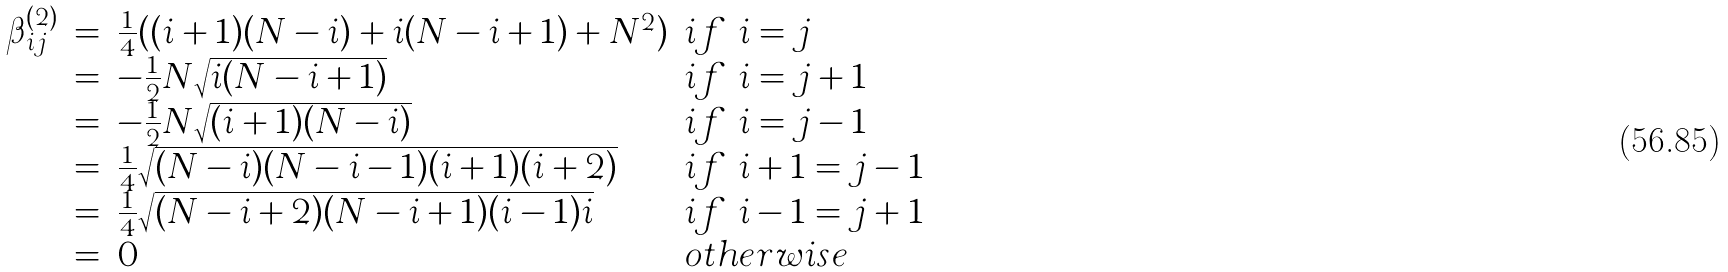<formula> <loc_0><loc_0><loc_500><loc_500>\begin{array} { l c l l } \beta ^ { ( 2 ) } _ { i j } & = & \frac { 1 } { 4 } ( ( i + 1 ) ( N - i ) + i ( N - i + 1 ) + N ^ { 2 } ) & i f \ i = j \\ & = & - \frac { 1 } { 2 } N \sqrt { i ( N - i + 1 ) } & i f \ i = j + 1 \\ & = & - \frac { 1 } { 2 } N \sqrt { ( i + 1 ) ( N - i ) } & i f \ i = j - 1 \\ & = & \frac { 1 } { 4 } \sqrt { ( N - i ) ( N - i - 1 ) ( i + 1 ) ( i + 2 ) } \ & i f \ i + 1 = j - 1 \\ & = & \frac { 1 } { 4 } \sqrt { ( N - i + 2 ) ( N - i + 1 ) ( i - 1 ) i } \ & i f \ i - 1 = j + 1 \\ & = & 0 & o t h e r w i s e \end{array}</formula> 